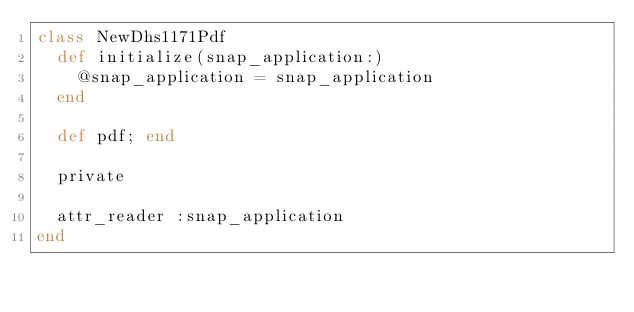Convert code to text. <code><loc_0><loc_0><loc_500><loc_500><_Ruby_>class NewDhs1171Pdf
  def initialize(snap_application:)
    @snap_application = snap_application
  end

  def pdf; end

  private

  attr_reader :snap_application
end
</code> 